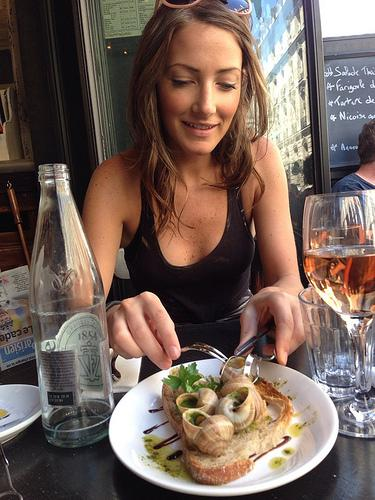Question: who is eating?
Choices:
A. The man.
B. The child.
C. A woman.
D. The dog.
Answer with the letter. Answer: C Question: what is in the bottle?
Choices:
A. Wine.
B. Beer.
C. Mineral water.
D. Water.
Answer with the letter. Answer: C Question: what is the woman eating?
Choices:
A. A hamburger.
B. A hot dog.
C. A snail sandwich.
D. A pickle.
Answer with the letter. Answer: C Question: when was this photo taken?
Choices:
A. During the night.
B. During the evening.
C. During the daytime.
D. In the morning.
Answer with the letter. Answer: C Question: why is she eating?
Choices:
A. She's hungry.
B. It's time to eat.
C. It's meal time.
D. It's dinner.
Answer with the letter. Answer: C 